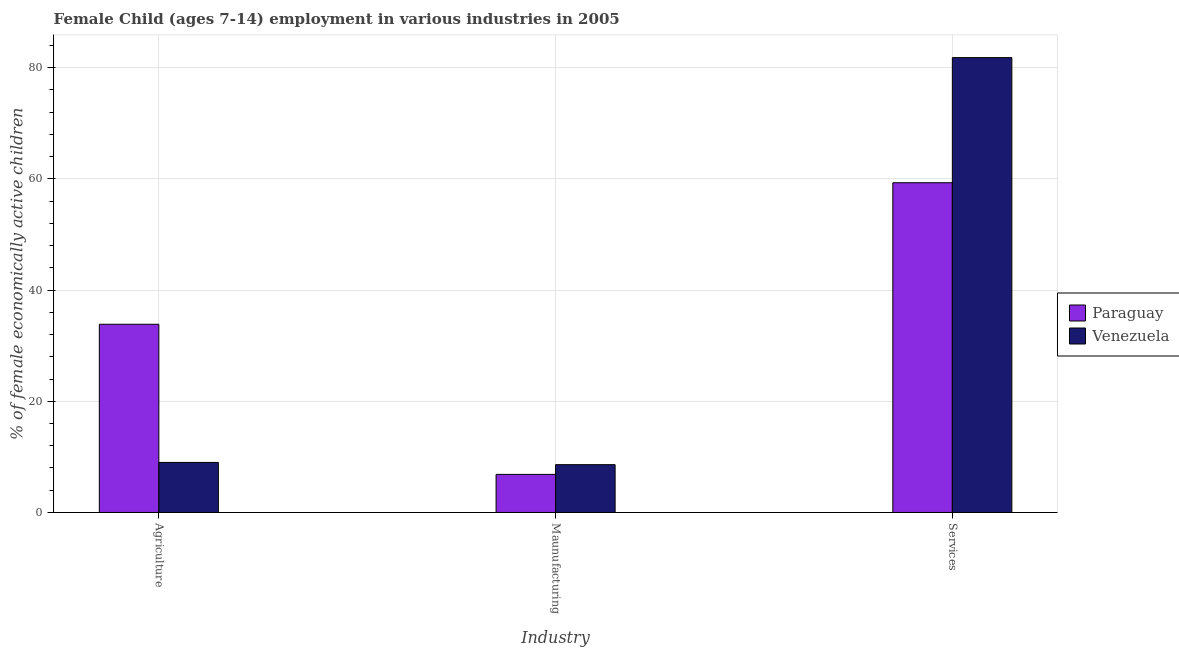Are the number of bars per tick equal to the number of legend labels?
Keep it short and to the point. Yes. What is the label of the 1st group of bars from the left?
Offer a terse response. Agriculture. Across all countries, what is the maximum percentage of economically active children in services?
Provide a succinct answer. 81.8. In which country was the percentage of economically active children in agriculture maximum?
Offer a very short reply. Paraguay. In which country was the percentage of economically active children in services minimum?
Your answer should be very brief. Paraguay. What is the total percentage of economically active children in agriculture in the graph?
Your answer should be very brief. 42.85. What is the difference between the percentage of economically active children in manufacturing in Paraguay and the percentage of economically active children in agriculture in Venezuela?
Offer a terse response. -2.15. What is the average percentage of economically active children in manufacturing per country?
Provide a short and direct response. 7.72. What is the difference between the percentage of economically active children in manufacturing and percentage of economically active children in services in Venezuela?
Keep it short and to the point. -73.2. What is the ratio of the percentage of economically active children in manufacturing in Paraguay to that in Venezuela?
Offer a very short reply. 0.8. What is the difference between the highest and the second highest percentage of economically active children in agriculture?
Make the answer very short. 24.85. In how many countries, is the percentage of economically active children in manufacturing greater than the average percentage of economically active children in manufacturing taken over all countries?
Your answer should be very brief. 1. Is the sum of the percentage of economically active children in manufacturing in Venezuela and Paraguay greater than the maximum percentage of economically active children in agriculture across all countries?
Provide a succinct answer. No. What does the 1st bar from the left in Agriculture represents?
Your answer should be very brief. Paraguay. What does the 1st bar from the right in Services represents?
Your answer should be very brief. Venezuela. Are the values on the major ticks of Y-axis written in scientific E-notation?
Your response must be concise. No. Does the graph contain any zero values?
Offer a terse response. No. Does the graph contain grids?
Provide a short and direct response. Yes. Where does the legend appear in the graph?
Offer a terse response. Center right. How many legend labels are there?
Make the answer very short. 2. How are the legend labels stacked?
Your response must be concise. Vertical. What is the title of the graph?
Offer a very short reply. Female Child (ages 7-14) employment in various industries in 2005. Does "Austria" appear as one of the legend labels in the graph?
Give a very brief answer. No. What is the label or title of the X-axis?
Your answer should be very brief. Industry. What is the label or title of the Y-axis?
Ensure brevity in your answer.  % of female economically active children. What is the % of female economically active children of Paraguay in Agriculture?
Keep it short and to the point. 33.85. What is the % of female economically active children in Venezuela in Agriculture?
Keep it short and to the point. 9. What is the % of female economically active children in Paraguay in Maunufacturing?
Offer a terse response. 6.85. What is the % of female economically active children in Venezuela in Maunufacturing?
Give a very brief answer. 8.6. What is the % of female economically active children of Paraguay in Services?
Provide a short and direct response. 59.3. What is the % of female economically active children of Venezuela in Services?
Your response must be concise. 81.8. Across all Industry, what is the maximum % of female economically active children of Paraguay?
Give a very brief answer. 59.3. Across all Industry, what is the maximum % of female economically active children in Venezuela?
Offer a very short reply. 81.8. Across all Industry, what is the minimum % of female economically active children in Paraguay?
Your answer should be very brief. 6.85. Across all Industry, what is the minimum % of female economically active children of Venezuela?
Your answer should be very brief. 8.6. What is the total % of female economically active children of Venezuela in the graph?
Provide a succinct answer. 99.4. What is the difference between the % of female economically active children in Paraguay in Agriculture and that in Maunufacturing?
Make the answer very short. 27. What is the difference between the % of female economically active children in Paraguay in Agriculture and that in Services?
Offer a terse response. -25.45. What is the difference between the % of female economically active children of Venezuela in Agriculture and that in Services?
Offer a terse response. -72.8. What is the difference between the % of female economically active children in Paraguay in Maunufacturing and that in Services?
Your answer should be very brief. -52.45. What is the difference between the % of female economically active children in Venezuela in Maunufacturing and that in Services?
Offer a very short reply. -73.2. What is the difference between the % of female economically active children in Paraguay in Agriculture and the % of female economically active children in Venezuela in Maunufacturing?
Your answer should be very brief. 25.25. What is the difference between the % of female economically active children of Paraguay in Agriculture and the % of female economically active children of Venezuela in Services?
Your answer should be compact. -47.95. What is the difference between the % of female economically active children in Paraguay in Maunufacturing and the % of female economically active children in Venezuela in Services?
Your response must be concise. -74.95. What is the average % of female economically active children in Paraguay per Industry?
Your response must be concise. 33.33. What is the average % of female economically active children in Venezuela per Industry?
Provide a succinct answer. 33.13. What is the difference between the % of female economically active children in Paraguay and % of female economically active children in Venezuela in Agriculture?
Your answer should be very brief. 24.85. What is the difference between the % of female economically active children in Paraguay and % of female economically active children in Venezuela in Maunufacturing?
Give a very brief answer. -1.75. What is the difference between the % of female economically active children in Paraguay and % of female economically active children in Venezuela in Services?
Keep it short and to the point. -22.5. What is the ratio of the % of female economically active children in Paraguay in Agriculture to that in Maunufacturing?
Your answer should be very brief. 4.94. What is the ratio of the % of female economically active children in Venezuela in Agriculture to that in Maunufacturing?
Provide a short and direct response. 1.05. What is the ratio of the % of female economically active children of Paraguay in Agriculture to that in Services?
Offer a terse response. 0.57. What is the ratio of the % of female economically active children of Venezuela in Agriculture to that in Services?
Keep it short and to the point. 0.11. What is the ratio of the % of female economically active children in Paraguay in Maunufacturing to that in Services?
Give a very brief answer. 0.12. What is the ratio of the % of female economically active children of Venezuela in Maunufacturing to that in Services?
Give a very brief answer. 0.11. What is the difference between the highest and the second highest % of female economically active children of Paraguay?
Your answer should be compact. 25.45. What is the difference between the highest and the second highest % of female economically active children of Venezuela?
Ensure brevity in your answer.  72.8. What is the difference between the highest and the lowest % of female economically active children in Paraguay?
Your answer should be very brief. 52.45. What is the difference between the highest and the lowest % of female economically active children of Venezuela?
Offer a very short reply. 73.2. 